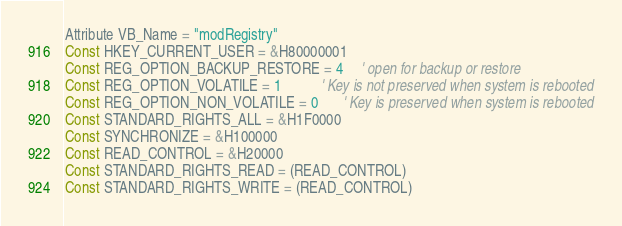<code> <loc_0><loc_0><loc_500><loc_500><_VisualBasic_>Attribute VB_Name = "modRegistry"
Const HKEY_CURRENT_USER = &H80000001
Const REG_OPTION_BACKUP_RESTORE = 4     ' open for backup or restore
Const REG_OPTION_VOLATILE = 1           ' Key is not preserved when system is rebooted
Const REG_OPTION_NON_VOLATILE = 0       ' Key is preserved when system is rebooted
Const STANDARD_RIGHTS_ALL = &H1F0000
Const SYNCHRONIZE = &H100000
Const READ_CONTROL = &H20000
Const STANDARD_RIGHTS_READ = (READ_CONTROL)
Const STANDARD_RIGHTS_WRITE = (READ_CONTROL)</code> 